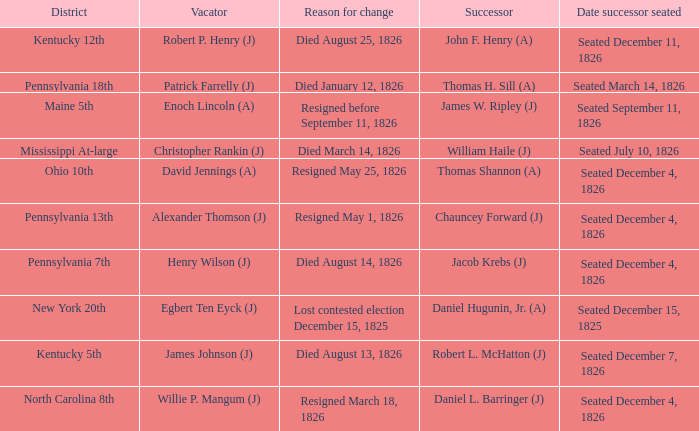Name the reason for change pennsylvania 13th Resigned May 1, 1826. 